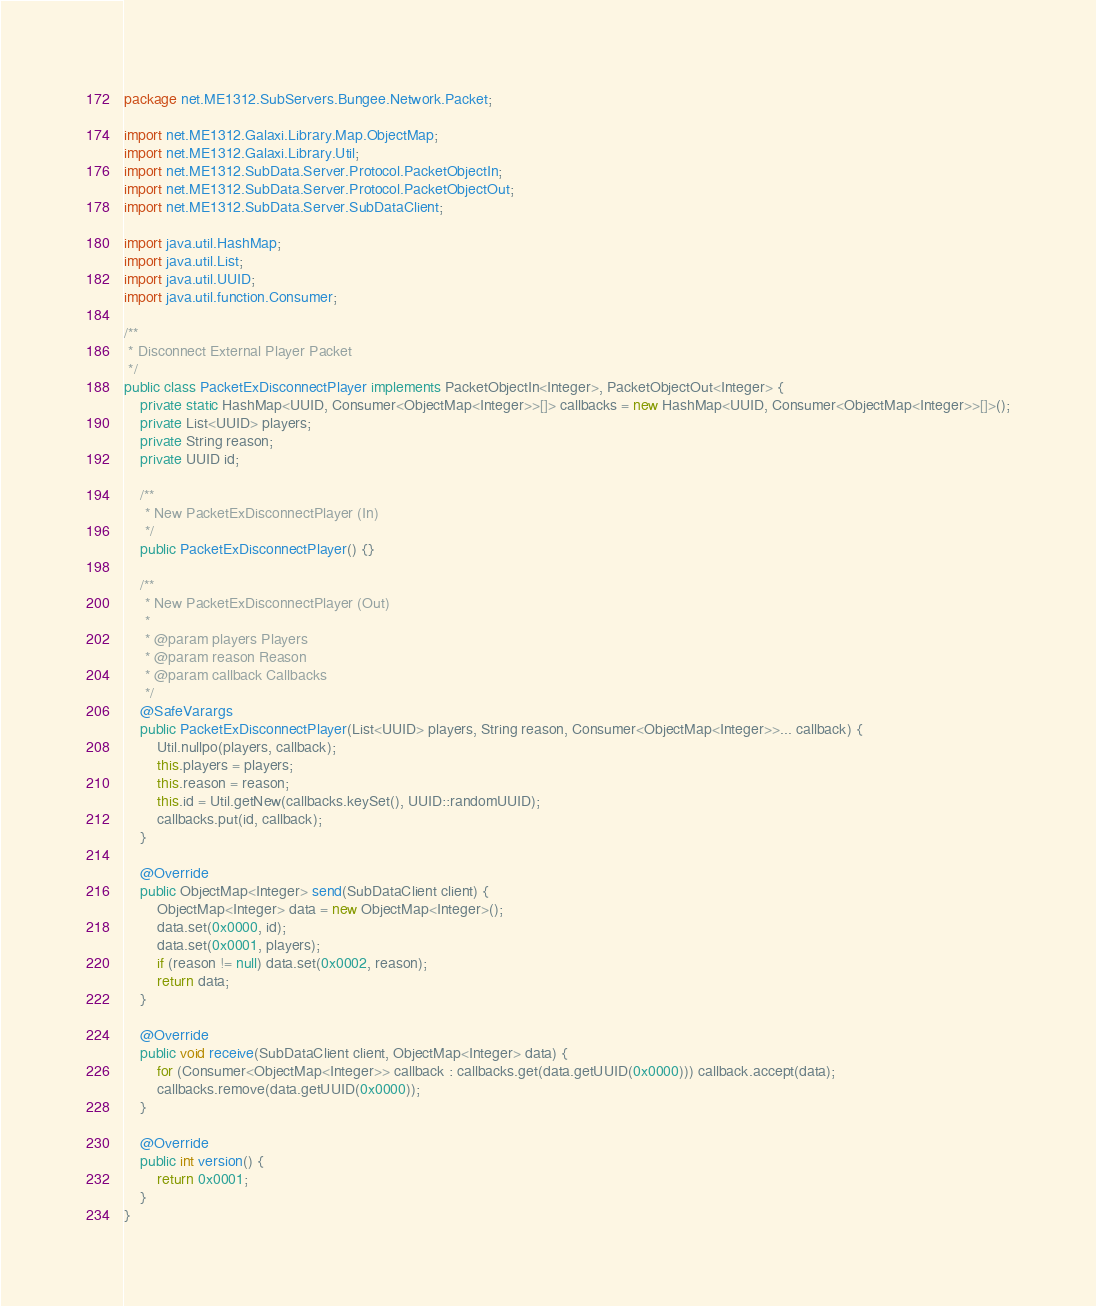Convert code to text. <code><loc_0><loc_0><loc_500><loc_500><_Java_>package net.ME1312.SubServers.Bungee.Network.Packet;

import net.ME1312.Galaxi.Library.Map.ObjectMap;
import net.ME1312.Galaxi.Library.Util;
import net.ME1312.SubData.Server.Protocol.PacketObjectIn;
import net.ME1312.SubData.Server.Protocol.PacketObjectOut;
import net.ME1312.SubData.Server.SubDataClient;

import java.util.HashMap;
import java.util.List;
import java.util.UUID;
import java.util.function.Consumer;

/**
 * Disconnect External Player Packet
 */
public class PacketExDisconnectPlayer implements PacketObjectIn<Integer>, PacketObjectOut<Integer> {
    private static HashMap<UUID, Consumer<ObjectMap<Integer>>[]> callbacks = new HashMap<UUID, Consumer<ObjectMap<Integer>>[]>();
    private List<UUID> players;
    private String reason;
    private UUID id;

    /**
     * New PacketExDisconnectPlayer (In)
     */
    public PacketExDisconnectPlayer() {}

    /**
     * New PacketExDisconnectPlayer (Out)
     *
     * @param players Players
     * @param reason Reason
     * @param callback Callbacks
     */
    @SafeVarargs
    public PacketExDisconnectPlayer(List<UUID> players, String reason, Consumer<ObjectMap<Integer>>... callback) {
        Util.nullpo(players, callback);
        this.players = players;
        this.reason = reason;
        this.id = Util.getNew(callbacks.keySet(), UUID::randomUUID);
        callbacks.put(id, callback);
    }

    @Override
    public ObjectMap<Integer> send(SubDataClient client) {
        ObjectMap<Integer> data = new ObjectMap<Integer>();
        data.set(0x0000, id);
        data.set(0x0001, players);
        if (reason != null) data.set(0x0002, reason);
        return data;
    }

    @Override
    public void receive(SubDataClient client, ObjectMap<Integer> data) {
        for (Consumer<ObjectMap<Integer>> callback : callbacks.get(data.getUUID(0x0000))) callback.accept(data);
        callbacks.remove(data.getUUID(0x0000));
    }

    @Override
    public int version() {
        return 0x0001;
    }
}
</code> 